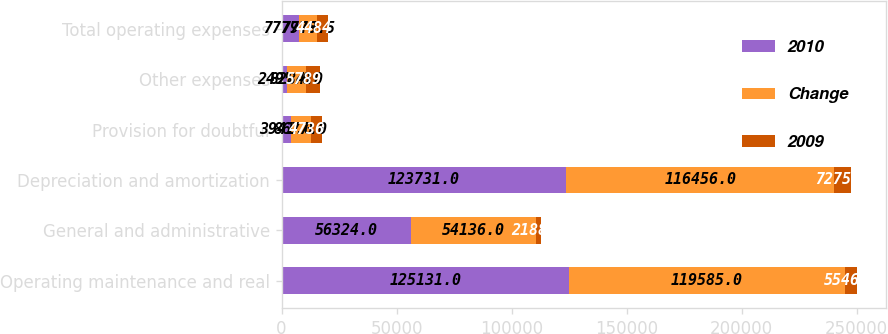<chart> <loc_0><loc_0><loc_500><loc_500><stacked_bar_chart><ecel><fcel>Operating maintenance and real<fcel>General and administrative<fcel>Depreciation and amortization<fcel>Provision for doubtful<fcel>Other expenses<fcel>Total operating expenses<nl><fcel>2010<fcel>125131<fcel>56324<fcel>123731<fcel>3941<fcel>2495<fcel>7779.5<nl><fcel>Change<fcel>119585<fcel>54136<fcel>116456<fcel>8677<fcel>8284<fcel>7779.5<nl><fcel>2009<fcel>5546<fcel>2188<fcel>7275<fcel>4736<fcel>5789<fcel>4484<nl></chart> 